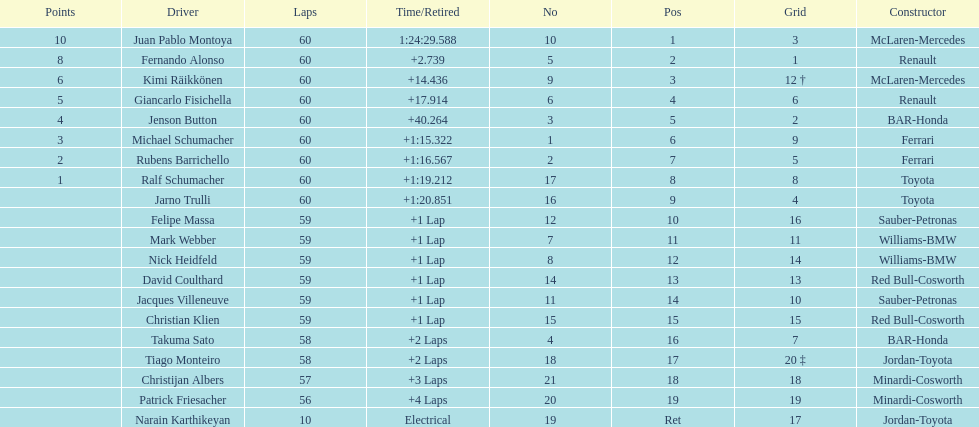How many racers were awarded points after the race? 8. 